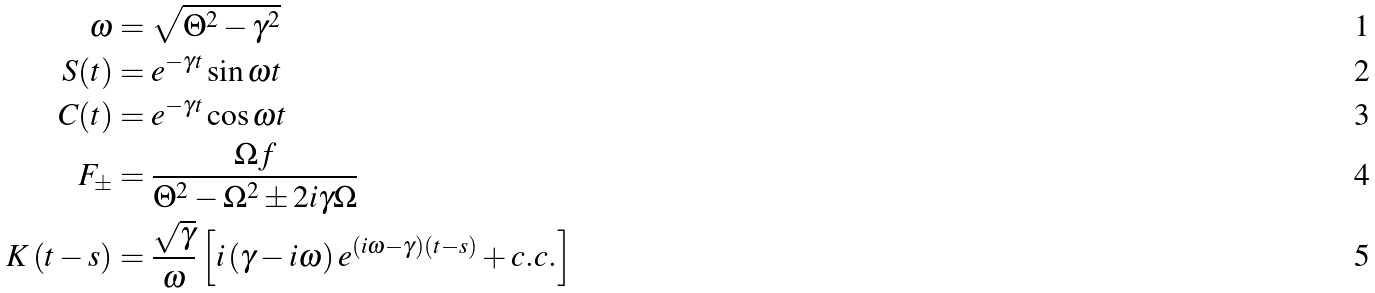Convert formula to latex. <formula><loc_0><loc_0><loc_500><loc_500>\omega & = \sqrt { \Theta ^ { 2 } - \gamma ^ { 2 } } \\ S ( t ) & = e ^ { - \gamma t } \sin \omega t \\ C ( t ) & = e ^ { - \gamma t } \cos \omega t \\ F _ { \pm } & = \frac { \Omega f } { \Theta ^ { 2 } - \Omega ^ { 2 } \pm 2 i \gamma \Omega } \\ K \left ( t - s \right ) & = \frac { \sqrt { \gamma } } { \omega } \left [ i \left ( \gamma - i \omega \right ) e ^ { \left ( i \omega - \gamma \right ) \left ( t - s \right ) } + c . c . \right ]</formula> 